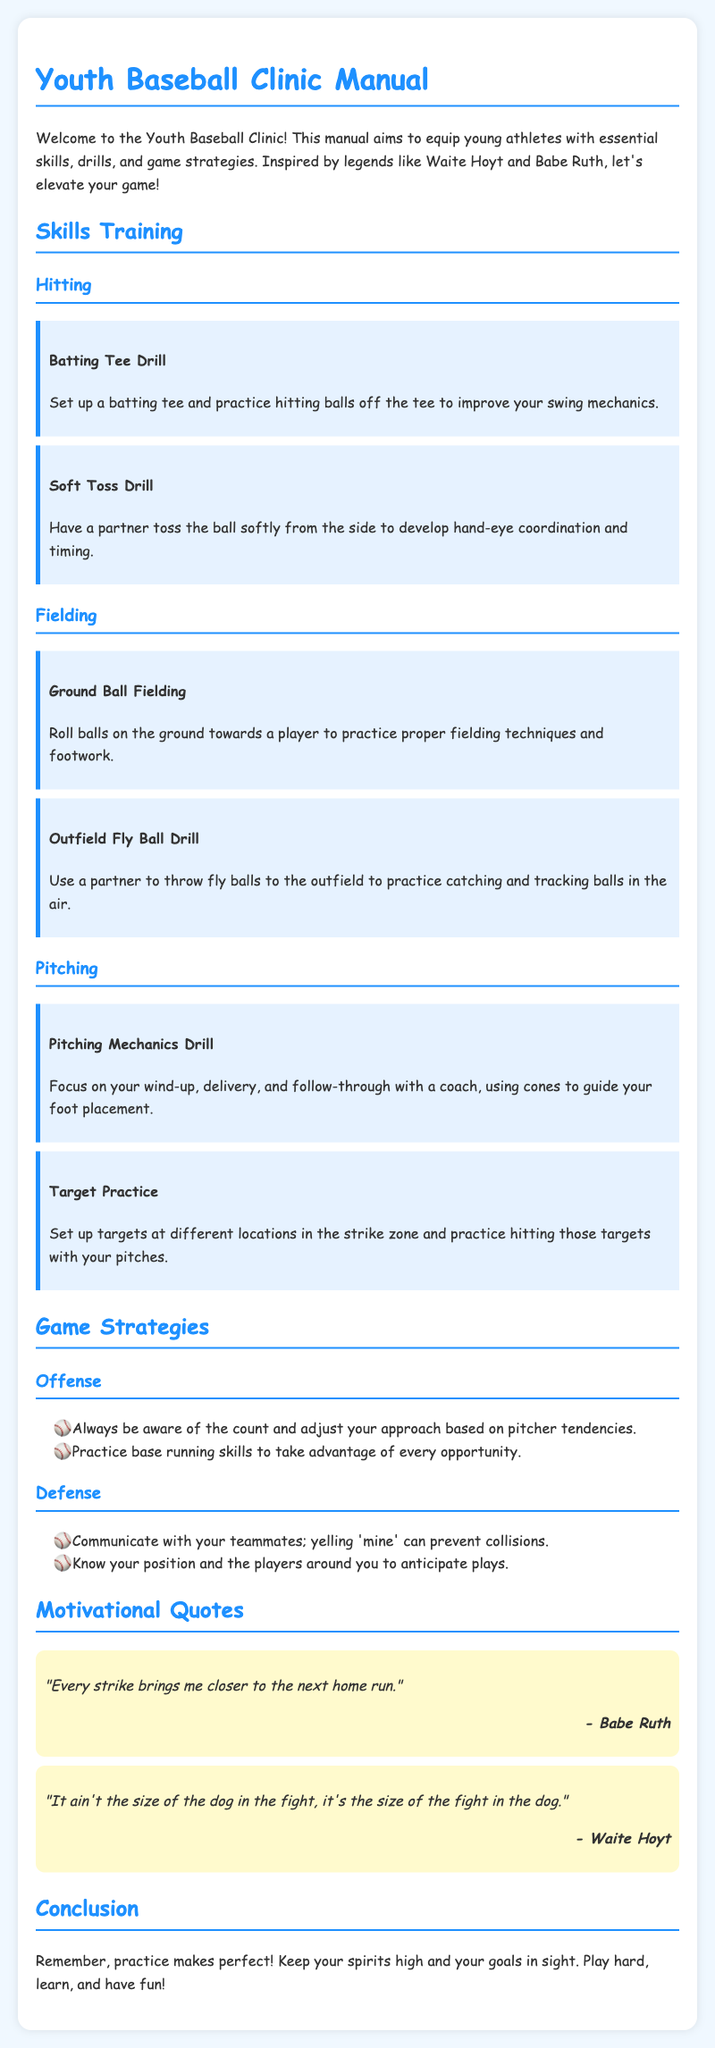What is the title of the manual? The title of the manual is stated at the beginning of the document.
Answer: Youth Baseball Clinic Manual Who is the author of the motivational quote, "Every strike brings me closer to the next home run"? This quote is attributed to a legendary baseball player mentioned in the quotes section.
Answer: Babe Ruth What drill focuses on set up a batting tee? The drilling focusing on a batting tee is described under the hitting section.
Answer: Batting Tee Drill What are players encouraged to yell to prevent collisions? The manual suggests a term that players should communicate loudly to avoid accidents.
Answer: mine What should players practice to take advantage of opportunities? This refers to skills that enhance players’ effectiveness during a game situation in the offense section.
Answer: base running skills What do players focus on during the Pitching Mechanics Drill? This drill emphasizes a specific aspect of pitching that is crucial for young athletes.
Answer: wind-up, delivery, and follow-through 